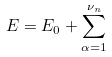<formula> <loc_0><loc_0><loc_500><loc_500>E = E _ { 0 } + \sum _ { \alpha = 1 } ^ { \nu _ { n } }</formula> 